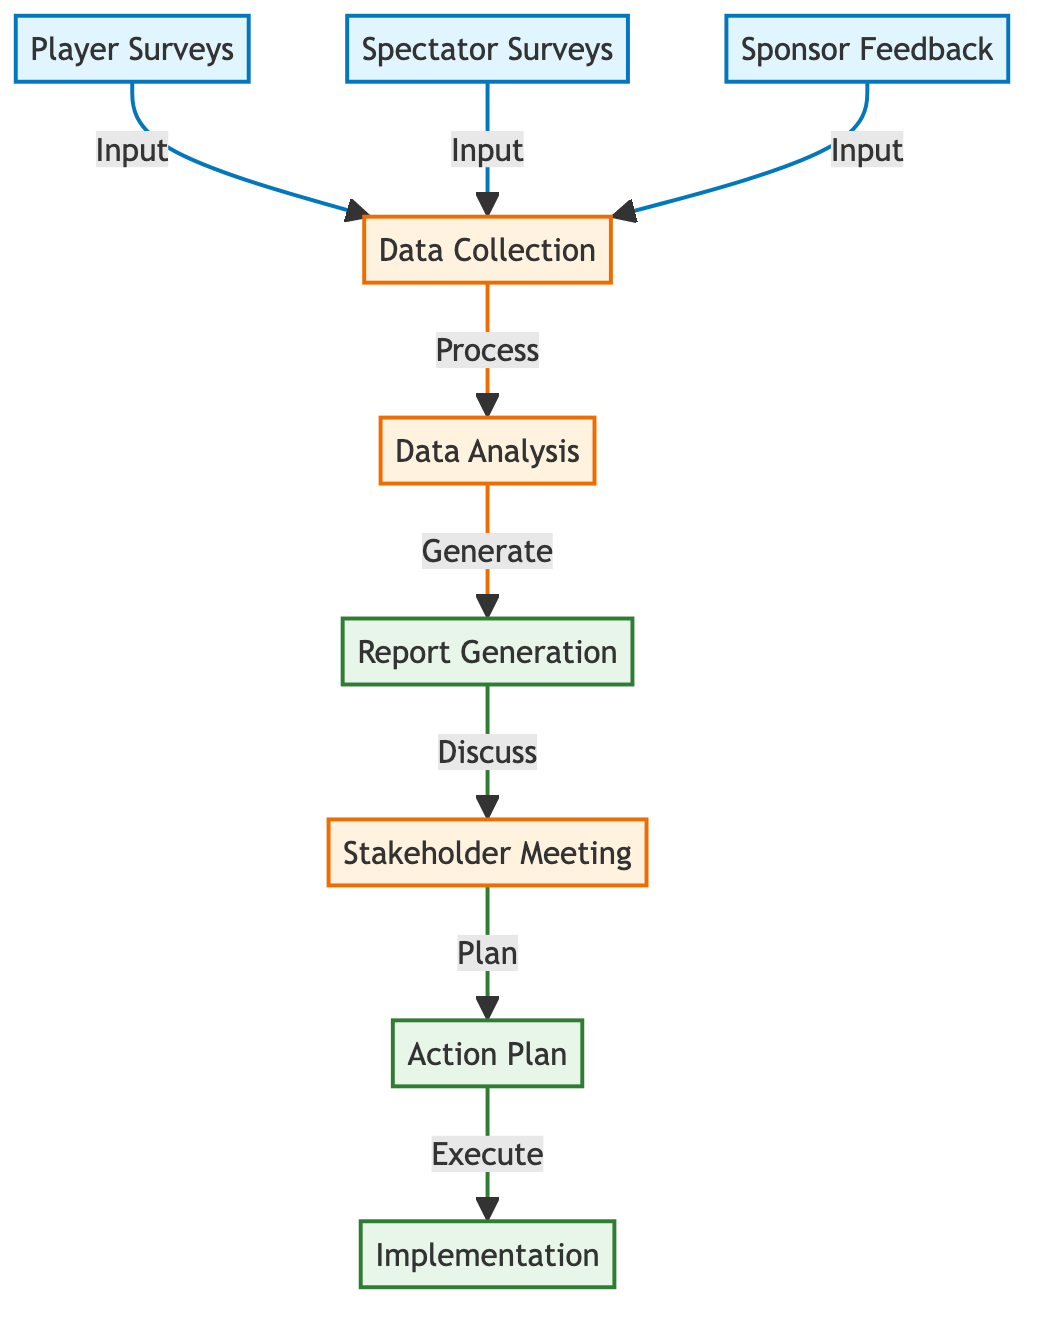How many nodes are in the diagram? The diagram lists nine nodes, which are Player Surveys, Spectator Surveys, Sponsor Feedback, Data Collection, Data Analysis, Report Generation, Stakeholder Meeting, Action Plan, and Implementation.
Answer: Nine What type of feedback does the Player Surveys node collect? The Player Surveys node collects detailed feedback on course conditions, event organization, and overall experience, as detailed in its description.
Answer: Detailed feedback Which node comes after Data Collection? After Data Collection, the next node in the flow is Data Analysis, which processes the compiled data.
Answer: Data Analysis What is the final output of the feedback loop? The final output, indicated by the last node in the diagram, is Implementation, which involves executing the action plan based on the feedback analysis.
Answer: Implementation Which node summarizes feedback and analysis results? The Report Generation node focuses on summarizing feedback and analysis results, creating a comprehensive report.
Answer: Report Generation What relationship exists between Report Generation and Stakeholder Meeting? The relationship between Report Generation and Stakeholder Meeting is that the findings from the report are discussed in the Stakeholder Meeting, which is indicated by the label "Discuss."
Answer: Discuss What is the purpose of the Stakeholder Meeting? The purpose of the Stakeholder Meeting is to discuss findings from the report with sponsors, organizers, and key stakeholders to strategize improvements based on feedback.
Answer: Discuss findings Which nodes serve as inputs to Data Collection? The inputs to Data Collection are Player Surveys, Spectator Surveys, and Sponsor Feedback, as indicated by the arrows pointing to the Data Collection node from these nodes.
Answer: Player Surveys, Spectator Surveys, Sponsor Feedback What does the Action Plan node entail? The Action Plan node involves developing a detailed strategy to address identified issues and enhance future events based on feedback received.
Answer: Develop a detailed plan 